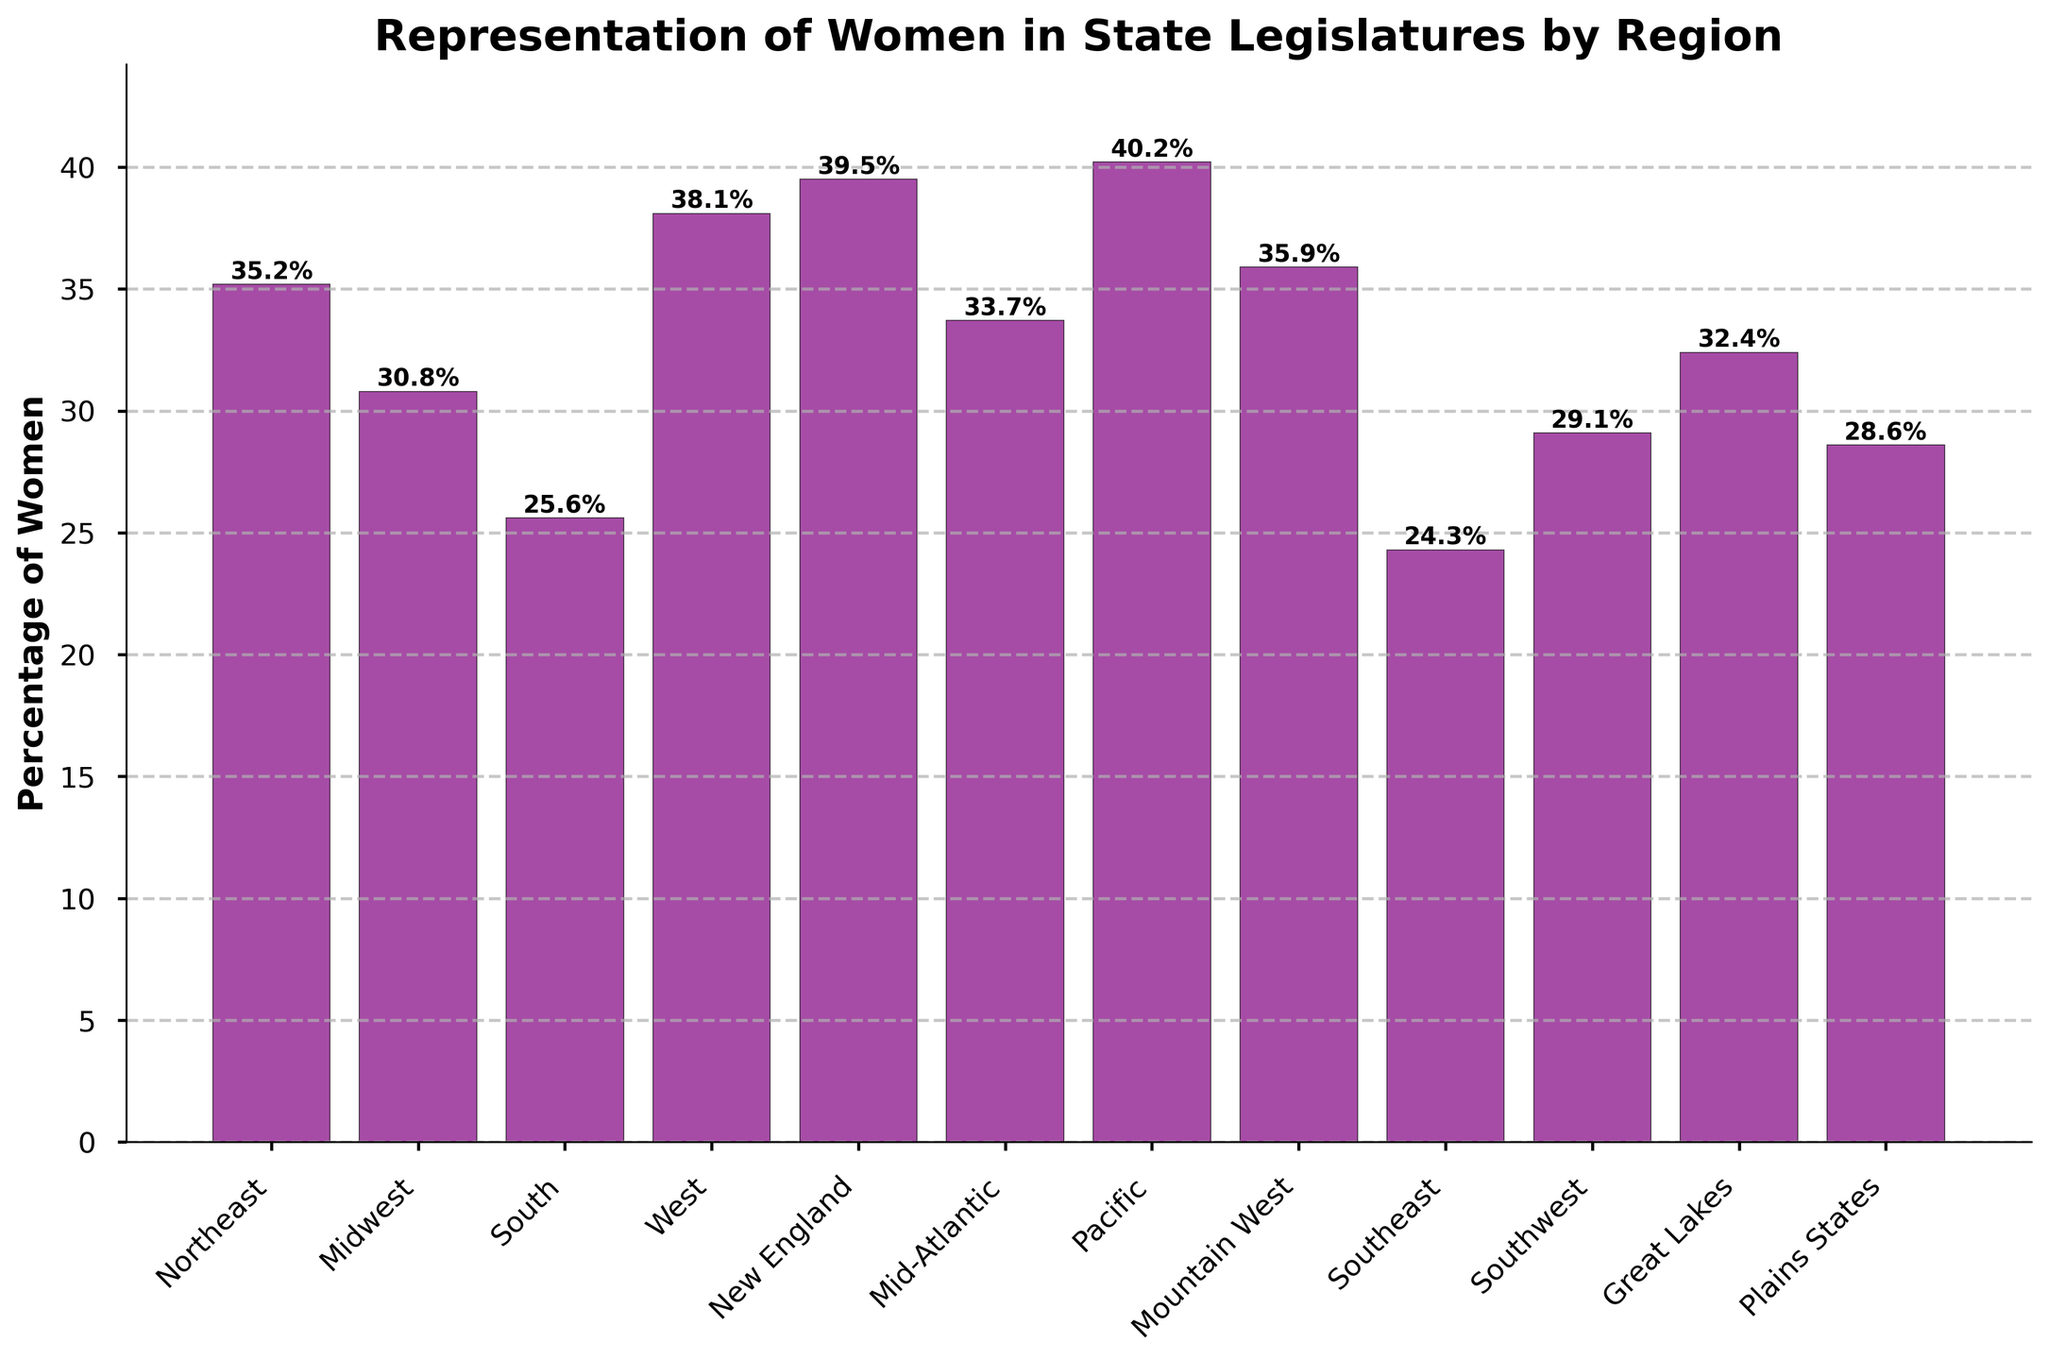What is the region with the highest percentage of women in state legislatures? The highest bar represents the Pacific region at 40.2%
Answer: Pacific Which regions have a percentage of women in state legislatures lower than 30%? By examining the heights of the bars, we can see that the South (25.6%), Southeast (24.3%), and Southwest (29.1%) have percentages below 30%
Answer: South, Southeast, Southwest What is the average percentage of women in state legislatures in the Northeast, Midwest, and South? Add the percentages: 35.2 (Northeast), 30.8 (Midwest), 25.6 (South) = 91.6. Divide by 3: 91.6 / 3 = 30.53
Answer: 30.53 Which region has closer representation of women to that of New England, the Plains States, or the Midwest? New England has 39.5%, Plains States 28.6%, and Midwest 30.8%. The difference between New England and Midwest is smaller (39.5 - 30.8 = 8.7) compared to New England and Plains States (39.5 - 28.6 = 10.9)
Answer: Midwest Is the percentage of women in state legislatures higher in the Mountain West or the Great Lakes? By comparing the bar heights, Mountain West is 35.9% and Great Lakes is 32.4%, so Mountain West is higher
Answer: Mountain West Which regions have percentages greater than the overall average percentage across all regions? First, calculate the overall average: Add all percentages (35.2 + 30.8 + 25.6 + 38.1 + 39.5 + 33.7 + 40.2 + 35.9 + 24.3 + 29.1 + 32.4 + 28.6 = 393.4). Divide by 12: 393.4 / 12 = 32.78. Regions with percentages greater than 32.78 are Northeast, West, New England, Mid-Atlantic, Pacific, Mountain West, Great Lakes
Answer: Northeast, West, New England, Mid-Atlantic, Pacific, Mountain West, Great Lakes If we combine the percentages of the top two regions, what would the total be? The top two regions are Pacific (40.2%) and New England (39.5%). Add them: 40.2 + 39.5 = 79.7%
Answer: 79.7 Among the Southern states listed (South, Southeast, and Southwest), which one has the highest percentage of women in state legislatures? By comparing the bars, the percentages are: South (25.6%), Southeast (24.3%), Southwest (29.1%). The highest among them is Southwest
Answer: Southwest What is the difference in the percentage of women in state legislatures between the region with the highest value and the region with the lowest value? The highest is Pacific (40.2%) and the lowest is Southeast (24.3%). Subtract the two: 40.2 - 24.3 = 15.9%
Answer: 15.9 What is the median percentage of women in state legislatures across all regions? Order the percentages: 24.3, 25.6, 28.6, 29.1, 30.8, 32.4, 33.7, 35.2, 35.9, 38.1, 39.5, 40.2. The median is the middle value of an ordered list, for 12 values: (32.4 + 33.7) / 2 = 33.05
Answer: 33.05 